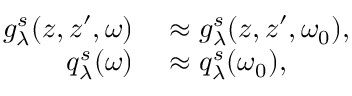<formula> <loc_0><loc_0><loc_500><loc_500>\begin{array} { r l } { g _ { \lambda } ^ { s } ( z , z ^ { \prime } , \omega ) } & \approx g _ { \lambda } ^ { s } ( z , z ^ { \prime } , \omega _ { 0 } ) , } \\ { q _ { \lambda } ^ { s } ( \omega ) } & \approx q _ { \lambda } ^ { s } ( \omega _ { 0 } ) , } \end{array}</formula> 